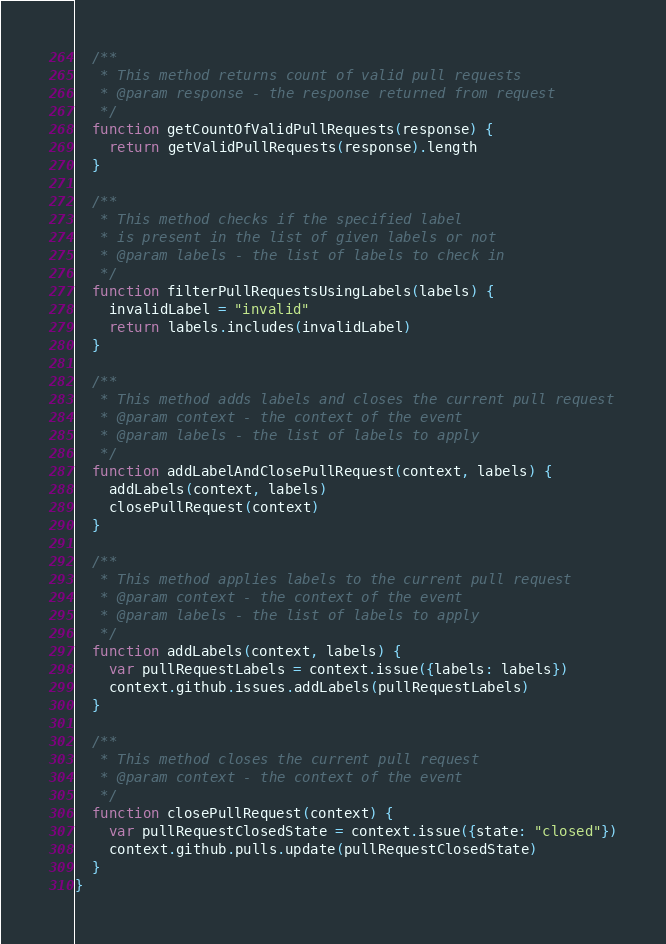<code> <loc_0><loc_0><loc_500><loc_500><_JavaScript_>  /**
   * This method returns count of valid pull requests
   * @param response - the response returned from request
   */
  function getCountOfValidPullRequests(response) {
    return getValidPullRequests(response).length
  }

  /**
   * This method checks if the specified label
   * is present in the list of given labels or not
   * @param labels - the list of labels to check in
   */
  function filterPullRequestsUsingLabels(labels) {
    invalidLabel = "invalid"
    return labels.includes(invalidLabel)
  }

  /**
   * This method adds labels and closes the current pull request
   * @param context - the context of the event
   * @param labels - the list of labels to apply
   */
  function addLabelAndClosePullRequest(context, labels) {
    addLabels(context, labels)
    closePullRequest(context)
  }

  /**
   * This method applies labels to the current pull request
   * @param context - the context of the event
   * @param labels - the list of labels to apply
   */
  function addLabels(context, labels) {
    var pullRequestLabels = context.issue({labels: labels})
    context.github.issues.addLabels(pullRequestLabels)
  }

  /**
   * This method closes the current pull request
   * @param context - the context of the event
   */
  function closePullRequest(context) {
    var pullRequestClosedState = context.issue({state: "closed"})
    context.github.pulls.update(pullRequestClosedState)
  }
}
</code> 